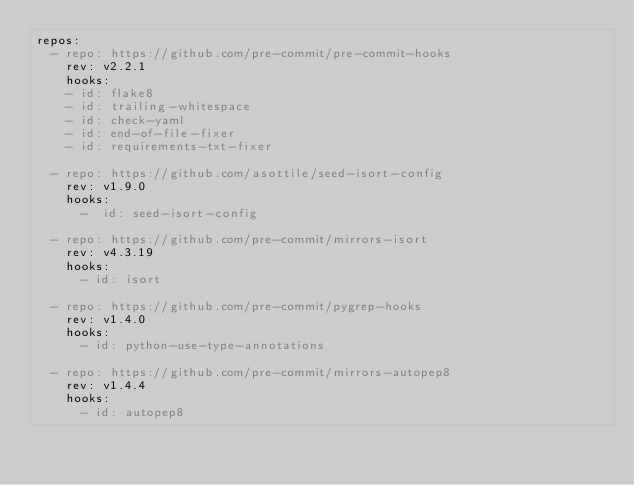Convert code to text. <code><loc_0><loc_0><loc_500><loc_500><_YAML_>repos:
  - repo: https://github.com/pre-commit/pre-commit-hooks
    rev: v2.2.1
    hooks:
    - id: flake8
    - id: trailing-whitespace
    - id: check-yaml
    - id: end-of-file-fixer
    - id: requirements-txt-fixer

  - repo: https://github.com/asottile/seed-isort-config
    rev: v1.9.0
    hooks:
      -  id: seed-isort-config

  - repo: https://github.com/pre-commit/mirrors-isort
    rev: v4.3.19
    hooks:
      - id: isort

  - repo: https://github.com/pre-commit/pygrep-hooks
    rev: v1.4.0
    hooks:
      - id: python-use-type-annotations

  - repo: https://github.com/pre-commit/mirrors-autopep8
    rev: v1.4.4
    hooks:
      - id: autopep8
</code> 